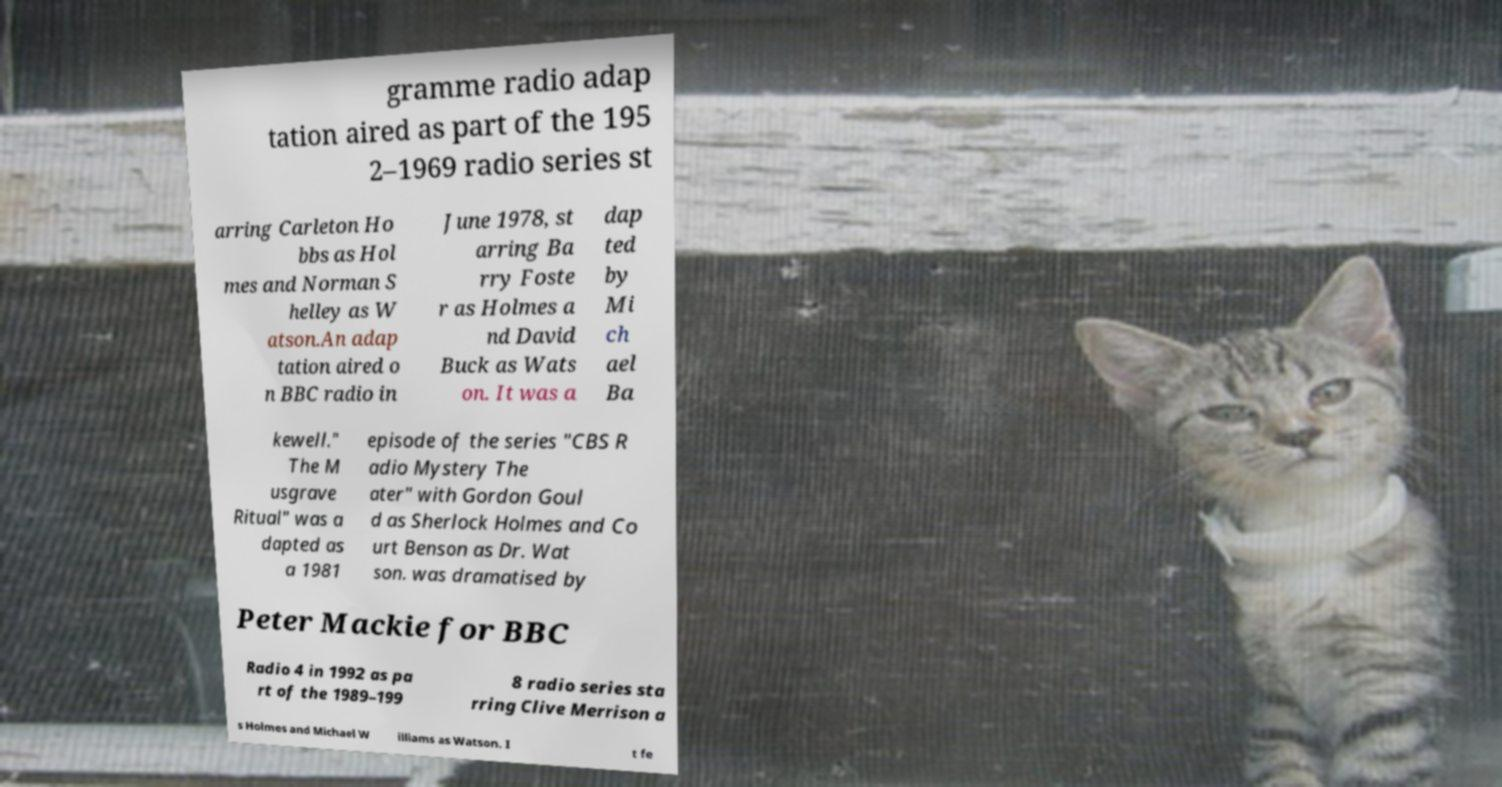Can you accurately transcribe the text from the provided image for me? gramme radio adap tation aired as part of the 195 2–1969 radio series st arring Carleton Ho bbs as Hol mes and Norman S helley as W atson.An adap tation aired o n BBC radio in June 1978, st arring Ba rry Foste r as Holmes a nd David Buck as Wats on. It was a dap ted by Mi ch ael Ba kewell." The M usgrave Ritual" was a dapted as a 1981 episode of the series "CBS R adio Mystery The ater" with Gordon Goul d as Sherlock Holmes and Co urt Benson as Dr. Wat son. was dramatised by Peter Mackie for BBC Radio 4 in 1992 as pa rt of the 1989–199 8 radio series sta rring Clive Merrison a s Holmes and Michael W illiams as Watson. I t fe 